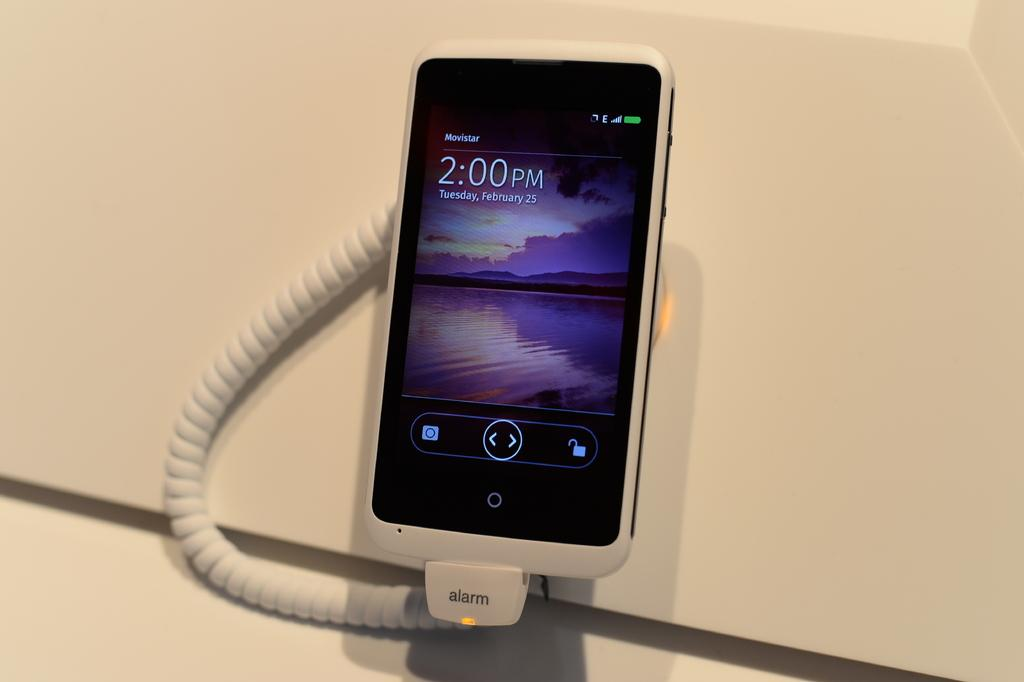<image>
Summarize the visual content of the image. Black cellphone that says the time is 2:00PM. 